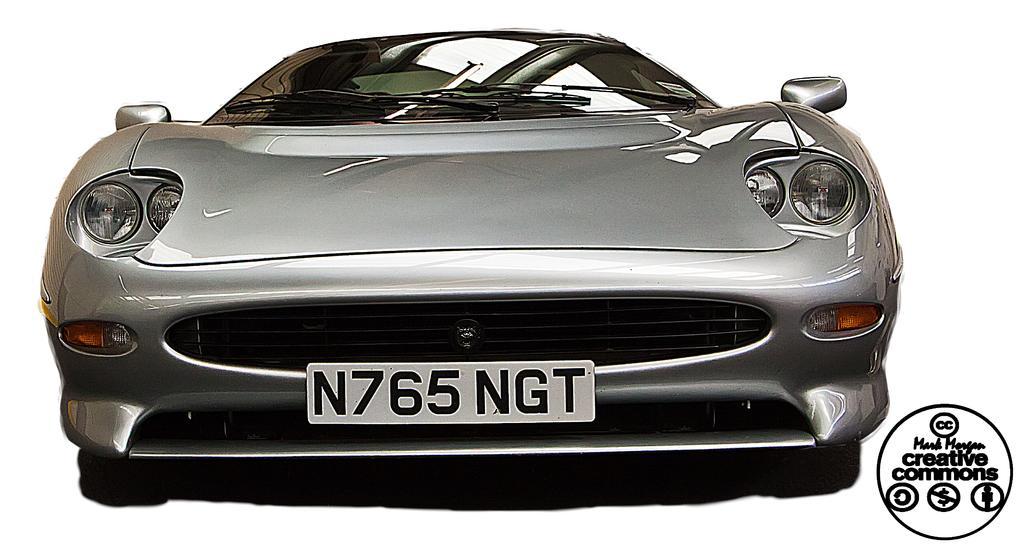Please provide a concise description of this image. In this image I can see a car and I can see a name plate attached to the car and background is white and on the right side I can see a text. 